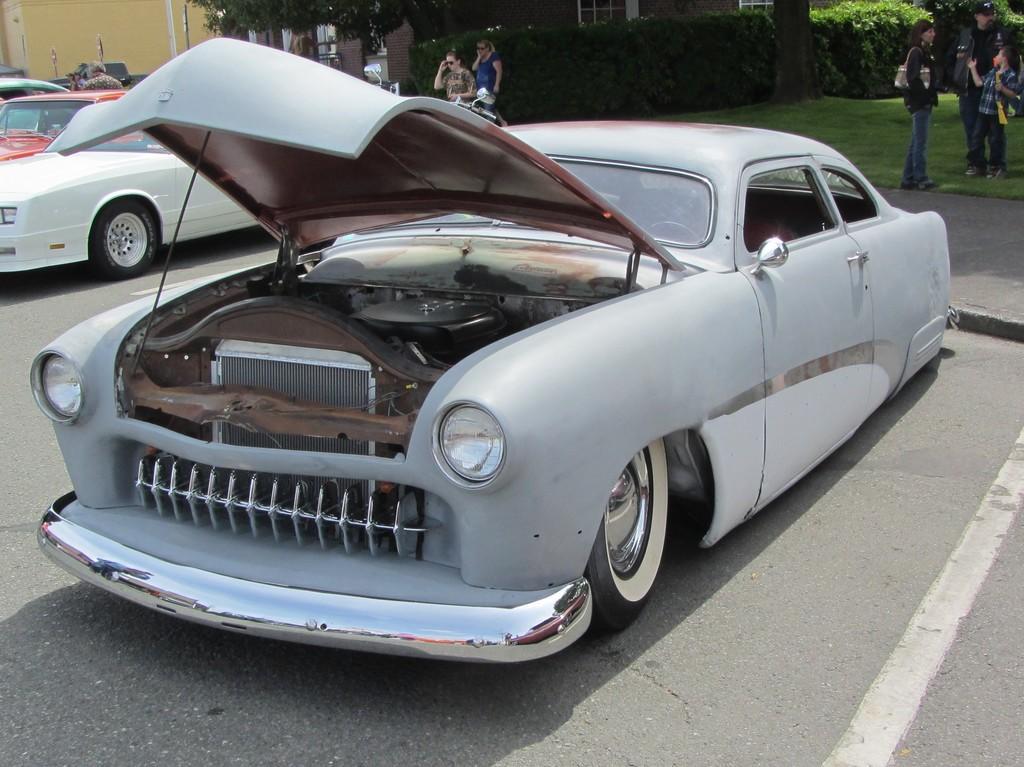Can you describe this image briefly? In the center of the image there are cars. In the background there are people standing and we can see trees and hedges. On the left there is a wall. At the bottom we can see a road. 